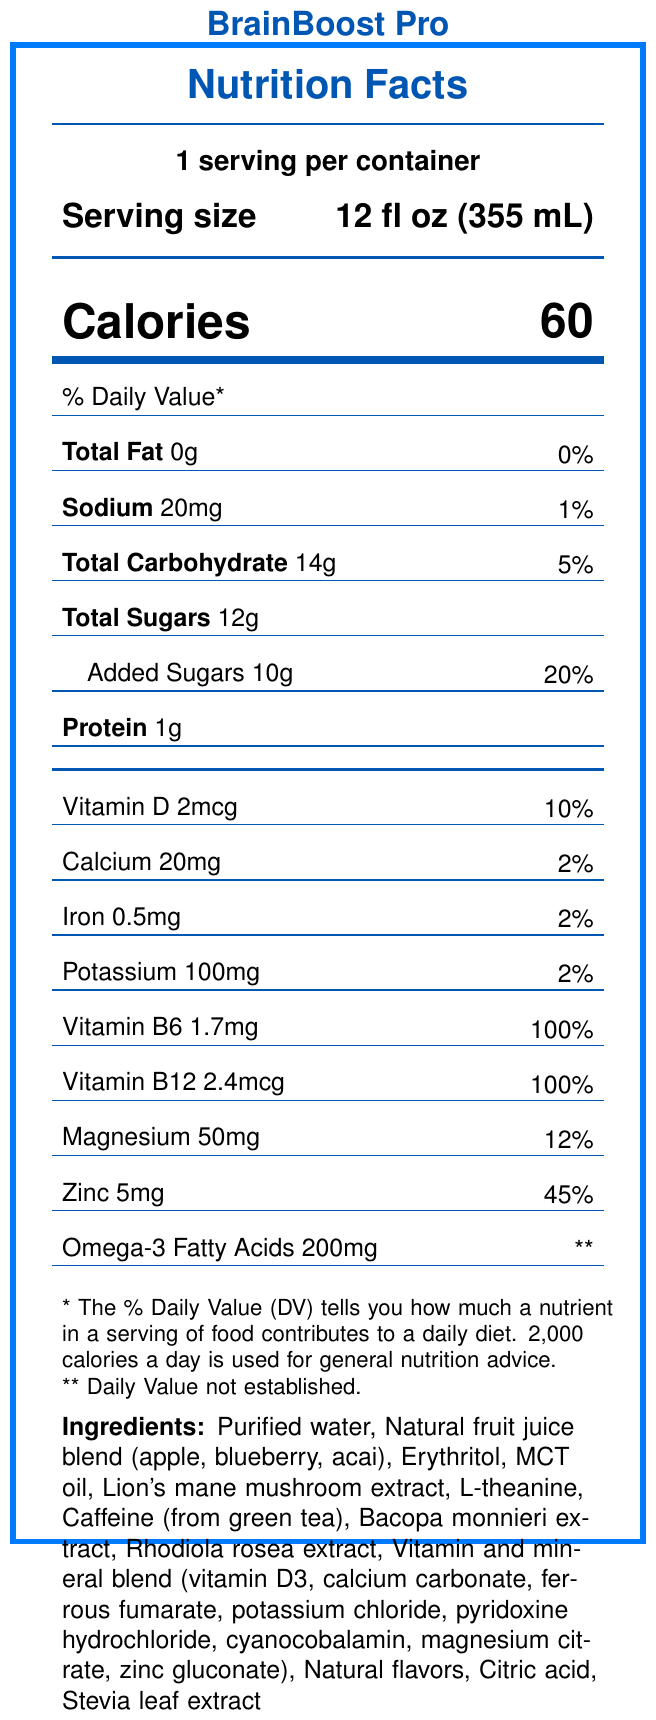What is the serving size of BrainBoost Pro? The serving size is explicitly stated as 12 fl oz (355 mL) in the serving information section.
Answer: 12 fl oz (355 mL) How many calories are there per serving? The number of calories per serving is indicated as 60 in the calories section of the document.
Answer: 60 How much sodium is in one serving and what is its % daily value? The document shows Sodium content as 20mg and the % daily value as 1%.
Answer: 20mg, 1% What are the main ingredients in BrainBoost Pro? The ingredients are listed in the ingredients section of the document.
Answer: Purified water, Natural fruit juice blend (apple, blueberry, acai), Erythritol, MCT oil, Lion's mane mushroom extract, L-theanine, Caffeine (from green tea), Bacopa monnieri extract, Rhodiola rosea extract, Vitamin and mineral blend (vitamin D3, calcium carbonate, ferrous fumarate, potassium chloride, pyridoxine hydrochloride, cyanocobalamin, magnesium citrate, zinc gluconate), Natural flavors, Citric acid, Stevia leaf extract How much protein does one serving contain? The document mentions that each serving contains 1g of protein.
Answer: 1g What is the % daily value of Vitamin B6 per serving? The % daily value of Vitamin B6 is given as 100% in the vitamin and mineral table.
Answer: 100% Which vitamin is provided at 100% of the daily value per serving? The document provides 100% daily value for both Vitamin B6 and Vitamin B12.
Answer: Vitamin B6 and Vitamin B12 How many milligrams of magnesium are there in a serving? The amount of magnesium per serving is stated as 50mg.
Answer: 50mg Which of the following statements is a regulatory disclaimer found on the label? A. "Supports cognitive function" B. "Manufactured in a GMP-certified facility" C. "These statements have not been evaluated by the Food and Drug Administration." D. "Store in a cool, dry place" The disclaimer about FDA evaluation is found under the functional claims section in the document.
Answer: C. "These statements have not been evaluated by the Food and Drug Administration." How many grams of added sugars does one serving contain? The added sugars content per serving is stated as 10g in the document.
Answer: 10g Which company manufactures BrainBoost Pro? A. NeuroCogniTech Solutions, Inc. B. HealthBoost Labs C. Cognitive Beverages Ltd. D. Memory Enhancer Corp. The manufacturer’s name is stated as NeuroCogniTech Solutions, Inc. in the manufacturer info section.
Answer: A. NeuroCogniTech Solutions, Inc. Does BrainBoost Pro comply with FDA regulations for dietary supplements? The document states that the product complies with FDA regulations for dietary supplements.
Answer: Yes How should BrainBoost Pro be stored after opening? The storage instructions indicate to refrigerate after opening and consume within 3 days.
Answer: Refrigerate after opening. Consume within 3 days of opening. Summarize the key information provided in this Nutrition Facts Label. The summary includes a comprehensive description of the key nutrient information, ingredients, manufacturer details, and functional claims outlined in the document.
Answer: BrainBoost Pro is a fortified functional beverage aimed at improving cognitive performance. It has a serving size of 12 fl oz, contains 60 calories per serving, 0g of total fat, 20mg of sodium, 14g of total carbohydrates (including 12g of sugars and 10g of added sugars), 1g of protein, and several vitamins and minerals such as Vitamin D, Calcium, Iron, Potassium, Vitamin B6, Vitamin B12, Magnesium, and Zinc. It also contains 200mg of Omega-3 Fatty Acids. The ingredients include purified water, natural fruit juice blends, and other functional ingredients like Lion's mane mushroom extract and L-theanine. It is manufactured by NeuroCogniTech Solutions, Inc., in a GMP-certified facility and complies with FDA regulations for dietary supplements. The product has claims related to supporting cognitive function, enhancing focus, and promoting memory. However, it includes a disclaimer that these statements have not been evaluated by the FDA. What specific cognitive benefits does the label claim BrainBoost Pro provides? The document lists these specific functional claims under the functional claims section.
Answer: Supports cognitive function, Enhances focus and mental clarity, Promotes memory and learning Do you get any Omega-3 Fatty Acids in each serving? The document lists 200mg of Omega-3 Fatty Acids per serving, although no daily value is established.
Answer: Yes How much calcium does each serving of BrainBoost Pro provide? The calcium content per serving is 20mg according to the vitamin and mineral table.
Answer: 20mg What is the address of the manufacturer of BrainBoost Pro? The manufacturer's address is provided in the manufacturer info section.
Answer: 123 Innovation Way, Silicon Valley, CA 94025 Which nutrient provided in the beverage has the highest % Daily Value per serving? A. Vitamin D B. Calcium C. Vitamin B6 D. Magnesium Vitamin B6 has a % Daily Value of 100%, which is the highest compared to other listed nutrients.
Answer: C. Vitamin B6 How much sugar is included in total carbohydrates per serving? The total sugars content per serving is given as 12g in the document.
Answer: 12g What is the purpose of including Lion's mane mushroom extract in the ingredients? The document lists the ingredient but does not specify the purpose or benefits of Lion's mane mushroom extract.
Answer: Not enough information 